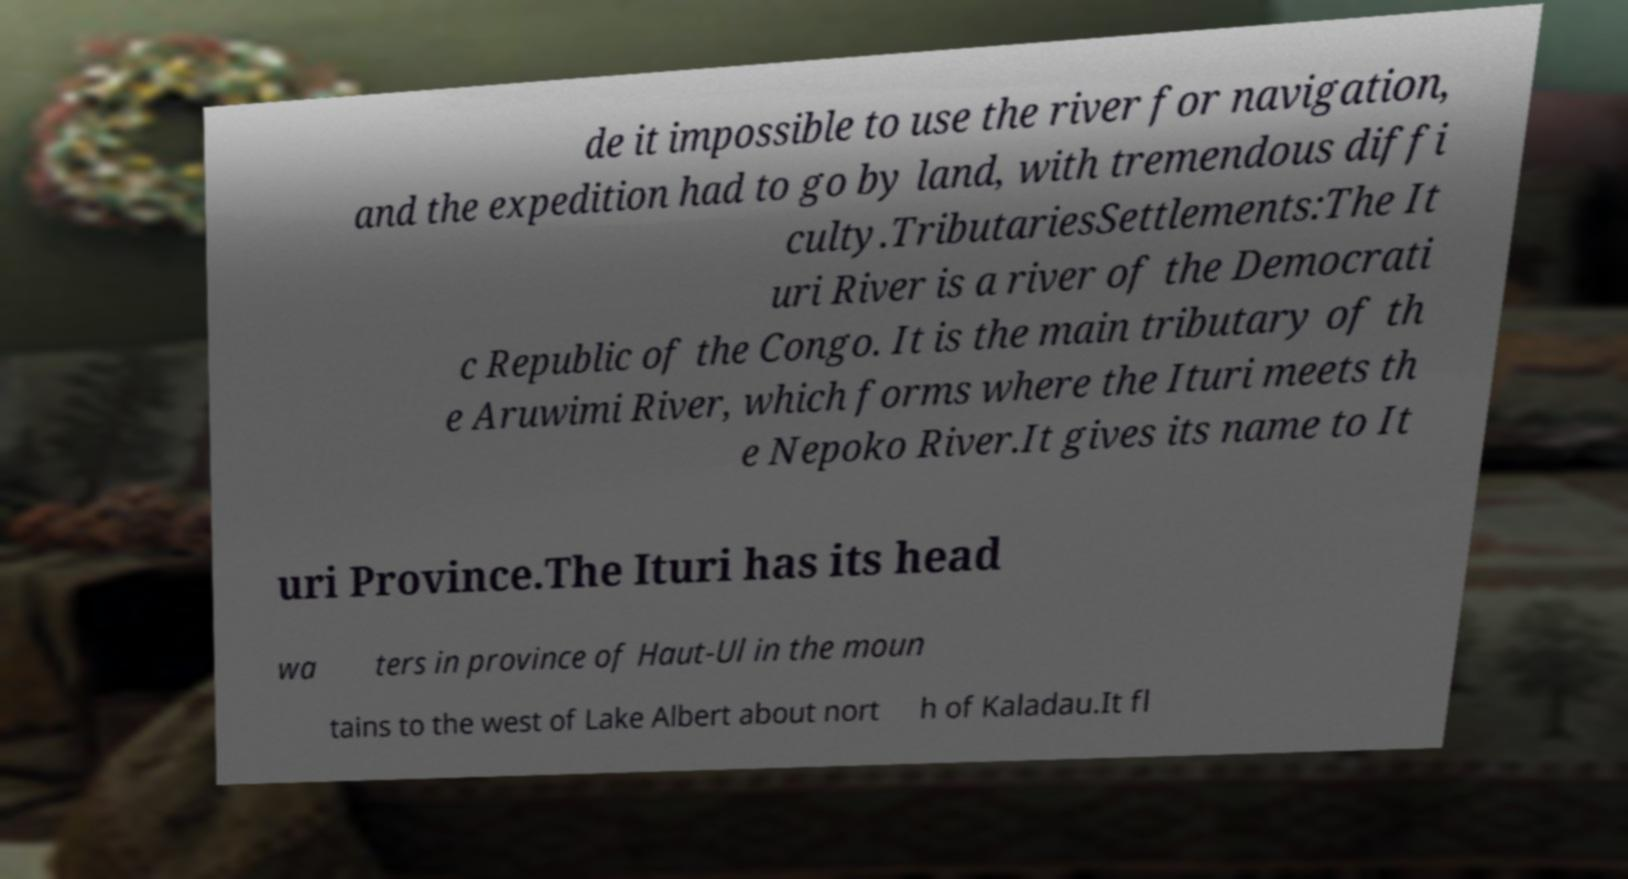Please identify and transcribe the text found in this image. de it impossible to use the river for navigation, and the expedition had to go by land, with tremendous diffi culty.TributariesSettlements:The It uri River is a river of the Democrati c Republic of the Congo. It is the main tributary of th e Aruwimi River, which forms where the Ituri meets th e Nepoko River.It gives its name to It uri Province.The Ituri has its head wa ters in province of Haut-Ul in the moun tains to the west of Lake Albert about nort h of Kaladau.It fl 